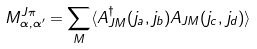Convert formula to latex. <formula><loc_0><loc_0><loc_500><loc_500>M ^ { J \pi } _ { \alpha , \alpha ^ { \prime } } = \sum _ { M } \langle A ^ { \dagger } _ { J M } ( j _ { a } , j _ { b } ) A _ { J M } ( j _ { c } , j _ { d } ) \rangle</formula> 